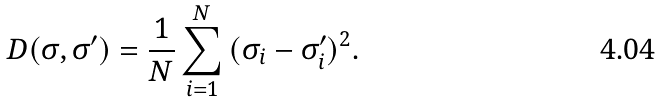Convert formula to latex. <formula><loc_0><loc_0><loc_500><loc_500>D ( \sigma , \sigma ^ { \prime } ) = \frac { 1 } { N } \sum _ { i = 1 } ^ { N } { ( \sigma _ { i } - \sigma _ { i } ^ { \prime } ) ^ { 2 } } .</formula> 